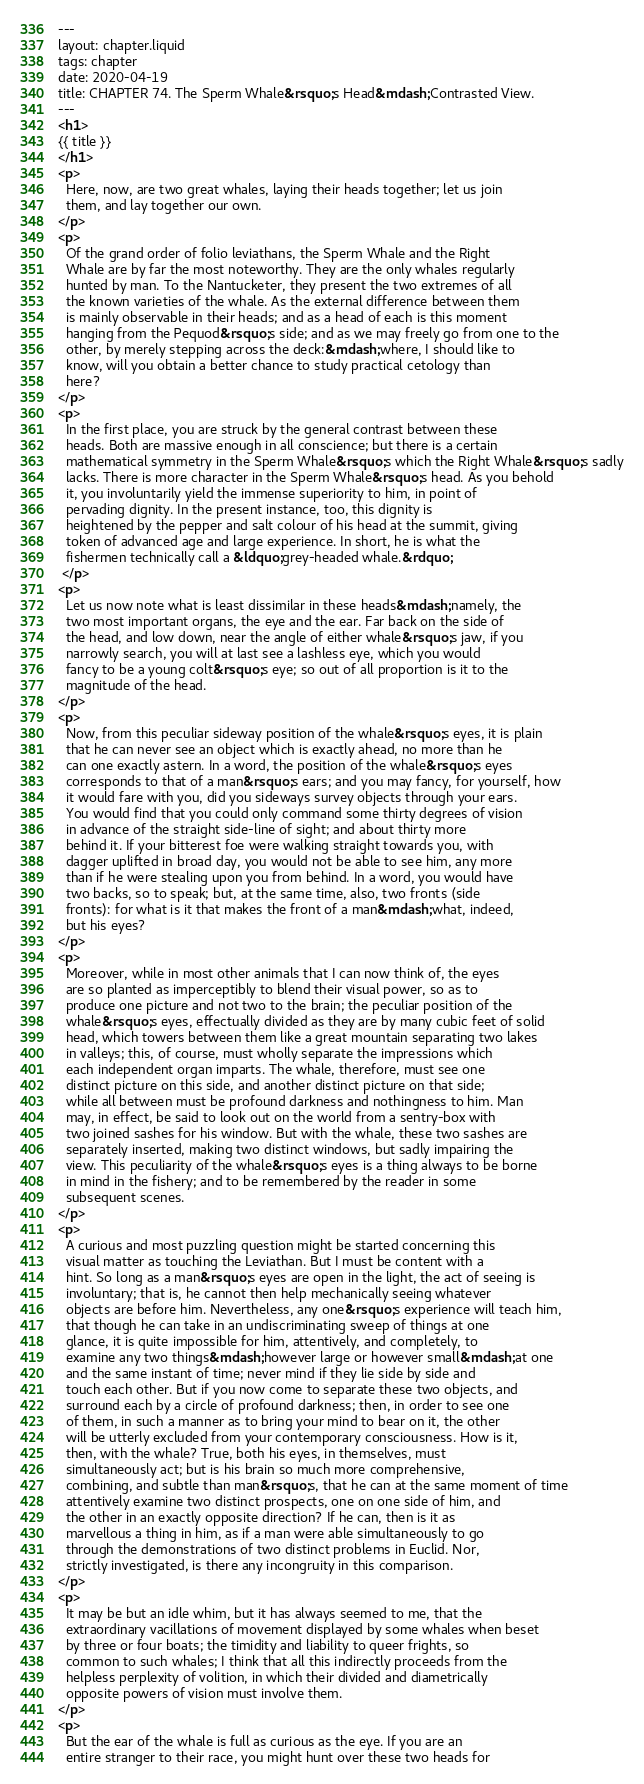Convert code to text. <code><loc_0><loc_0><loc_500><loc_500><_HTML_>---
layout: chapter.liquid
tags: chapter
date: 2020-04-19
title: CHAPTER 74. The Sperm Whale&rsquo;s Head&mdash;Contrasted View.
---
<h1>
{{ title }}
</h1>
<p>
  Here, now, are two great whales, laying their heads together; let us join
  them, and lay together our own.
</p>
<p>
  Of the grand order of folio leviathans, the Sperm Whale and the Right
  Whale are by far the most noteworthy. They are the only whales regularly
  hunted by man. To the Nantucketer, they present the two extremes of all
  the known varieties of the whale. As the external difference between them
  is mainly observable in their heads; and as a head of each is this moment
  hanging from the Pequod&rsquo;s side; and as we may freely go from one to the
  other, by merely stepping across the deck:&mdash;where, I should like to
  know, will you obtain a better chance to study practical cetology than
  here?
</p>
<p>
  In the first place, you are struck by the general contrast between these
  heads. Both are massive enough in all conscience; but there is a certain
  mathematical symmetry in the Sperm Whale&rsquo;s which the Right Whale&rsquo;s sadly
  lacks. There is more character in the Sperm Whale&rsquo;s head. As you behold
  it, you involuntarily yield the immense superiority to him, in point of
  pervading dignity. In the present instance, too, this dignity is
  heightened by the pepper and salt colour of his head at the summit, giving
  token of advanced age and large experience. In short, he is what the
  fishermen technically call a &ldquo;grey-headed whale.&rdquo;
 </p>
<p>
  Let us now note what is least dissimilar in these heads&mdash;namely, the
  two most important organs, the eye and the ear. Far back on the side of
  the head, and low down, near the angle of either whale&rsquo;s jaw, if you
  narrowly search, you will at last see a lashless eye, which you would
  fancy to be a young colt&rsquo;s eye; so out of all proportion is it to the
  magnitude of the head.
</p>
<p>
  Now, from this peculiar sideway position of the whale&rsquo;s eyes, it is plain
  that he can never see an object which is exactly ahead, no more than he
  can one exactly astern. In a word, the position of the whale&rsquo;s eyes
  corresponds to that of a man&rsquo;s ears; and you may fancy, for yourself, how
  it would fare with you, did you sideways survey objects through your ears.
  You would find that you could only command some thirty degrees of vision
  in advance of the straight side-line of sight; and about thirty more
  behind it. If your bitterest foe were walking straight towards you, with
  dagger uplifted in broad day, you would not be able to see him, any more
  than if he were stealing upon you from behind. In a word, you would have
  two backs, so to speak; but, at the same time, also, two fronts (side
  fronts): for what is it that makes the front of a man&mdash;what, indeed,
  but his eyes?
</p>
<p>
  Moreover, while in most other animals that I can now think of, the eyes
  are so planted as imperceptibly to blend their visual power, so as to
  produce one picture and not two to the brain; the peculiar position of the
  whale&rsquo;s eyes, effectually divided as they are by many cubic feet of solid
  head, which towers between them like a great mountain separating two lakes
  in valleys; this, of course, must wholly separate the impressions which
  each independent organ imparts. The whale, therefore, must see one
  distinct picture on this side, and another distinct picture on that side;
  while all between must be profound darkness and nothingness to him. Man
  may, in effect, be said to look out on the world from a sentry-box with
  two joined sashes for his window. But with the whale, these two sashes are
  separately inserted, making two distinct windows, but sadly impairing the
  view. This peculiarity of the whale&rsquo;s eyes is a thing always to be borne
  in mind in the fishery; and to be remembered by the reader in some
  subsequent scenes.
</p>
<p>
  A curious and most puzzling question might be started concerning this
  visual matter as touching the Leviathan. But I must be content with a
  hint. So long as a man&rsquo;s eyes are open in the light, the act of seeing is
  involuntary; that is, he cannot then help mechanically seeing whatever
  objects are before him. Nevertheless, any one&rsquo;s experience will teach him,
  that though he can take in an undiscriminating sweep of things at one
  glance, it is quite impossible for him, attentively, and completely, to
  examine any two things&mdash;however large or however small&mdash;at one
  and the same instant of time; never mind if they lie side by side and
  touch each other. But if you now come to separate these two objects, and
  surround each by a circle of profound darkness; then, in order to see one
  of them, in such a manner as to bring your mind to bear on it, the other
  will be utterly excluded from your contemporary consciousness. How is it,
  then, with the whale? True, both his eyes, in themselves, must
  simultaneously act; but is his brain so much more comprehensive,
  combining, and subtle than man&rsquo;s, that he can at the same moment of time
  attentively examine two distinct prospects, one on one side of him, and
  the other in an exactly opposite direction? If he can, then is it as
  marvellous a thing in him, as if a man were able simultaneously to go
  through the demonstrations of two distinct problems in Euclid. Nor,
  strictly investigated, is there any incongruity in this comparison.
</p>
<p>
  It may be but an idle whim, but it has always seemed to me, that the
  extraordinary vacillations of movement displayed by some whales when beset
  by three or four boats; the timidity and liability to queer frights, so
  common to such whales; I think that all this indirectly proceeds from the
  helpless perplexity of volition, in which their divided and diametrically
  opposite powers of vision must involve them.
</p>
<p>
  But the ear of the whale is full as curious as the eye. If you are an
  entire stranger to their race, you might hunt over these two heads for</code> 